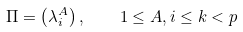<formula> <loc_0><loc_0><loc_500><loc_500>\Pi = \left ( \lambda ^ { A } _ { i } \right ) , \quad 1 \leq A , i \leq k < p</formula> 